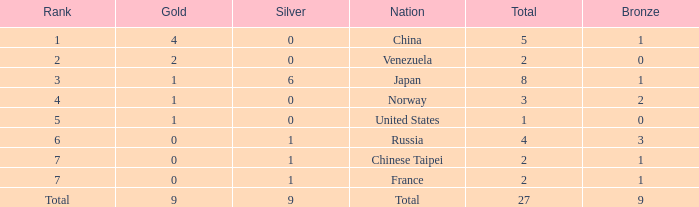What is the total number of Bronze when gold is more than 1 and nation is total? 1.0. 